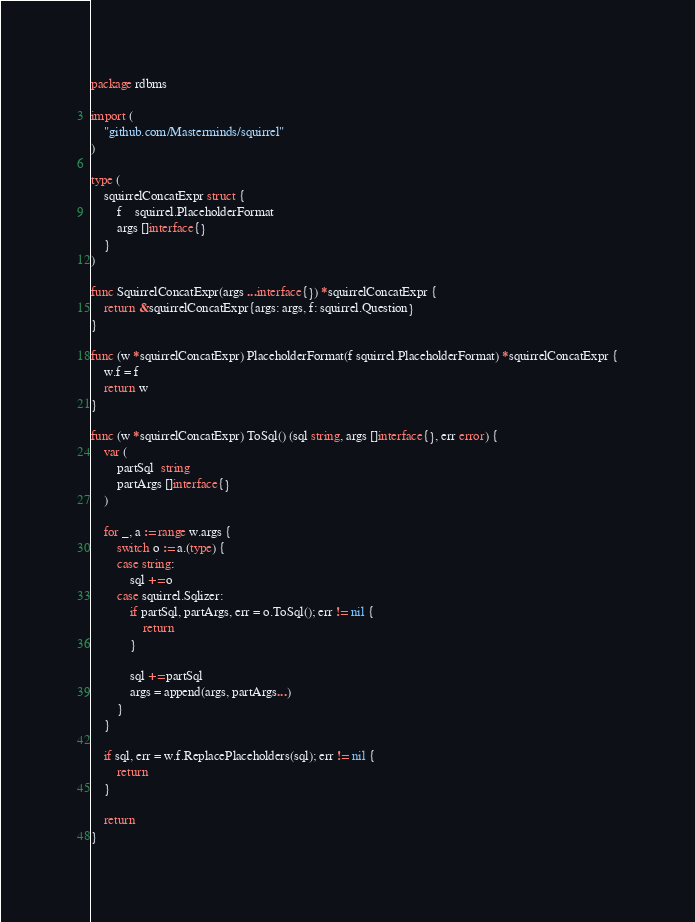Convert code to text. <code><loc_0><loc_0><loc_500><loc_500><_Go_>package rdbms

import (
	"github.com/Masterminds/squirrel"
)

type (
	squirrelConcatExpr struct {
		f    squirrel.PlaceholderFormat
		args []interface{}
	}
)

func SquirrelConcatExpr(args ...interface{}) *squirrelConcatExpr {
	return &squirrelConcatExpr{args: args, f: squirrel.Question}
}

func (w *squirrelConcatExpr) PlaceholderFormat(f squirrel.PlaceholderFormat) *squirrelConcatExpr {
	w.f = f
	return w
}

func (w *squirrelConcatExpr) ToSql() (sql string, args []interface{}, err error) {
	var (
		partSql  string
		partArgs []interface{}
	)

	for _, a := range w.args {
		switch o := a.(type) {
		case string:
			sql += o
		case squirrel.Sqlizer:
			if partSql, partArgs, err = o.ToSql(); err != nil {
				return
			}

			sql += partSql
			args = append(args, partArgs...)
		}
	}

	if sql, err = w.f.ReplacePlaceholders(sql); err != nil {
		return
	}

	return
}
</code> 